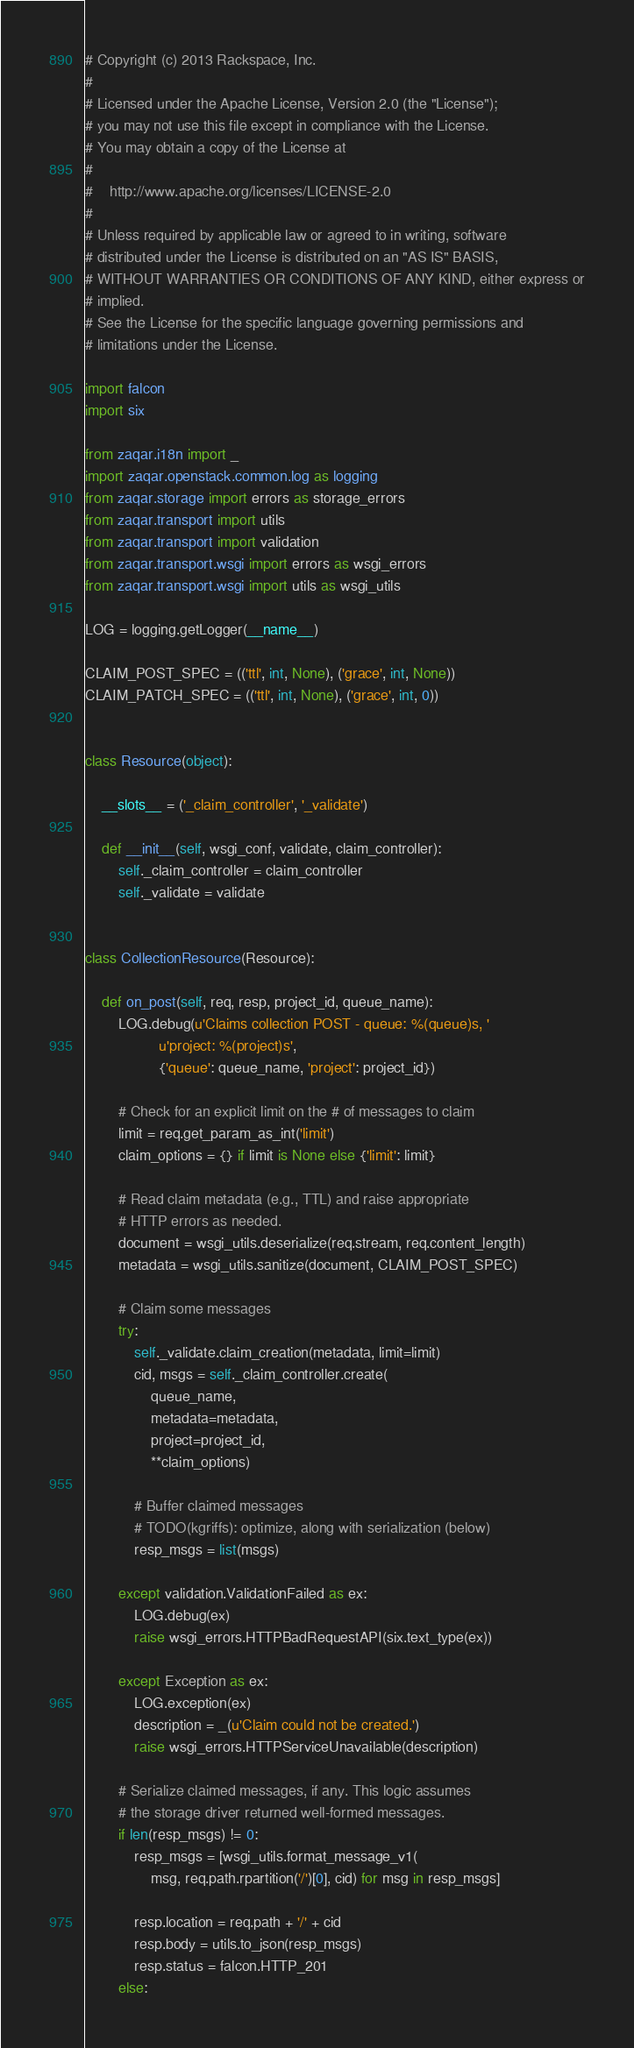Convert code to text. <code><loc_0><loc_0><loc_500><loc_500><_Python_># Copyright (c) 2013 Rackspace, Inc.
#
# Licensed under the Apache License, Version 2.0 (the "License");
# you may not use this file except in compliance with the License.
# You may obtain a copy of the License at
#
#    http://www.apache.org/licenses/LICENSE-2.0
#
# Unless required by applicable law or agreed to in writing, software
# distributed under the License is distributed on an "AS IS" BASIS,
# WITHOUT WARRANTIES OR CONDITIONS OF ANY KIND, either express or
# implied.
# See the License for the specific language governing permissions and
# limitations under the License.

import falcon
import six

from zaqar.i18n import _
import zaqar.openstack.common.log as logging
from zaqar.storage import errors as storage_errors
from zaqar.transport import utils
from zaqar.transport import validation
from zaqar.transport.wsgi import errors as wsgi_errors
from zaqar.transport.wsgi import utils as wsgi_utils

LOG = logging.getLogger(__name__)

CLAIM_POST_SPEC = (('ttl', int, None), ('grace', int, None))
CLAIM_PATCH_SPEC = (('ttl', int, None), ('grace', int, 0))


class Resource(object):

    __slots__ = ('_claim_controller', '_validate')

    def __init__(self, wsgi_conf, validate, claim_controller):
        self._claim_controller = claim_controller
        self._validate = validate


class CollectionResource(Resource):

    def on_post(self, req, resp, project_id, queue_name):
        LOG.debug(u'Claims collection POST - queue: %(queue)s, '
                  u'project: %(project)s',
                  {'queue': queue_name, 'project': project_id})

        # Check for an explicit limit on the # of messages to claim
        limit = req.get_param_as_int('limit')
        claim_options = {} if limit is None else {'limit': limit}

        # Read claim metadata (e.g., TTL) and raise appropriate
        # HTTP errors as needed.
        document = wsgi_utils.deserialize(req.stream, req.content_length)
        metadata = wsgi_utils.sanitize(document, CLAIM_POST_SPEC)

        # Claim some messages
        try:
            self._validate.claim_creation(metadata, limit=limit)
            cid, msgs = self._claim_controller.create(
                queue_name,
                metadata=metadata,
                project=project_id,
                **claim_options)

            # Buffer claimed messages
            # TODO(kgriffs): optimize, along with serialization (below)
            resp_msgs = list(msgs)

        except validation.ValidationFailed as ex:
            LOG.debug(ex)
            raise wsgi_errors.HTTPBadRequestAPI(six.text_type(ex))

        except Exception as ex:
            LOG.exception(ex)
            description = _(u'Claim could not be created.')
            raise wsgi_errors.HTTPServiceUnavailable(description)

        # Serialize claimed messages, if any. This logic assumes
        # the storage driver returned well-formed messages.
        if len(resp_msgs) != 0:
            resp_msgs = [wsgi_utils.format_message_v1(
                msg, req.path.rpartition('/')[0], cid) for msg in resp_msgs]

            resp.location = req.path + '/' + cid
            resp.body = utils.to_json(resp_msgs)
            resp.status = falcon.HTTP_201
        else:</code> 